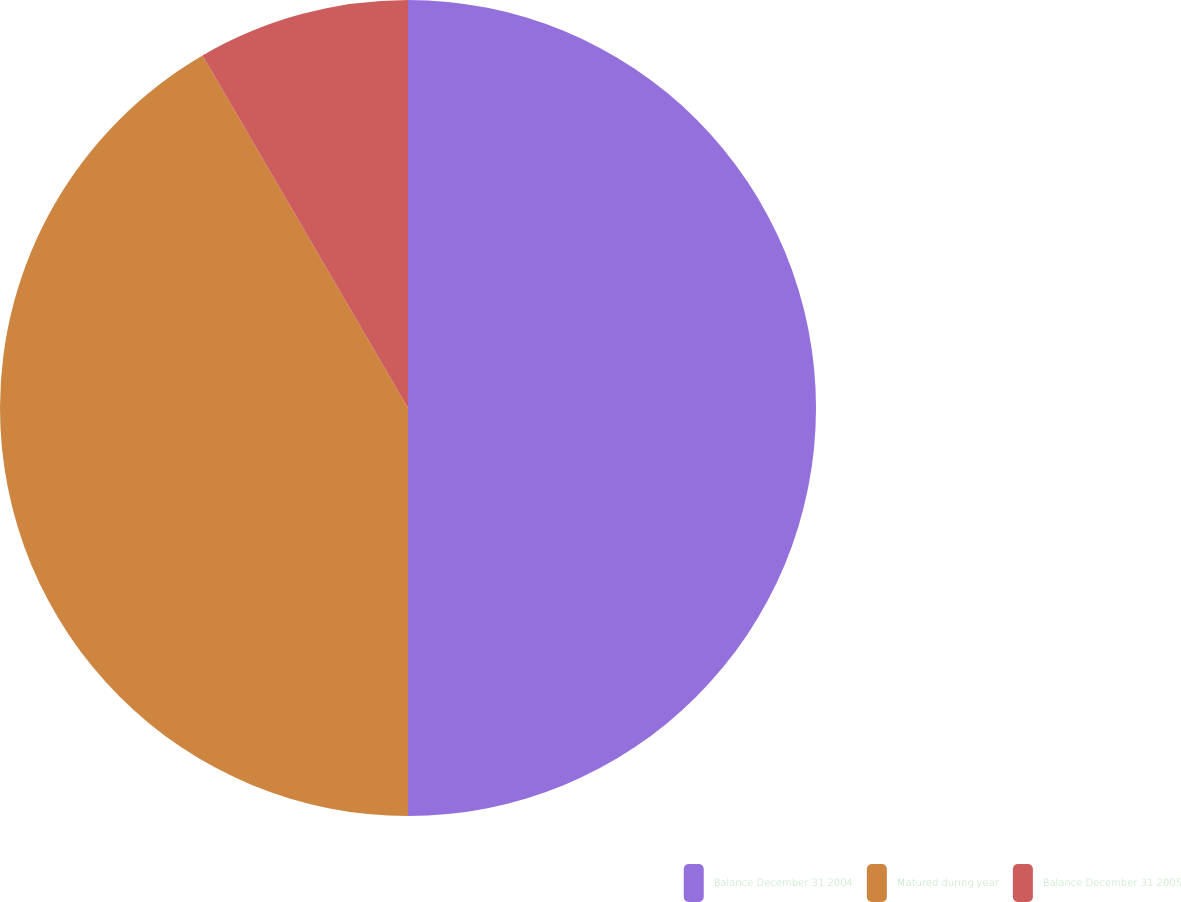<chart> <loc_0><loc_0><loc_500><loc_500><pie_chart><fcel>Balance December 31 2004<fcel>Matured during year<fcel>Balance December 31 2005<nl><fcel>50.0%<fcel>41.6%<fcel>8.4%<nl></chart> 